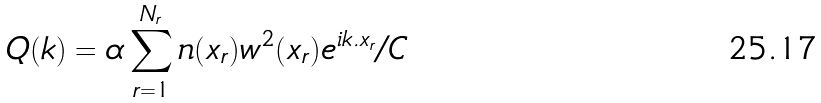Convert formula to latex. <formula><loc_0><loc_0><loc_500><loc_500>Q ( { k } ) = \alpha \sum _ { r = 1 } ^ { N _ { r } } n ( x _ { r } ) w ^ { 2 } ( x _ { r } ) e ^ { i { k } . { x } _ { r } } / C</formula> 